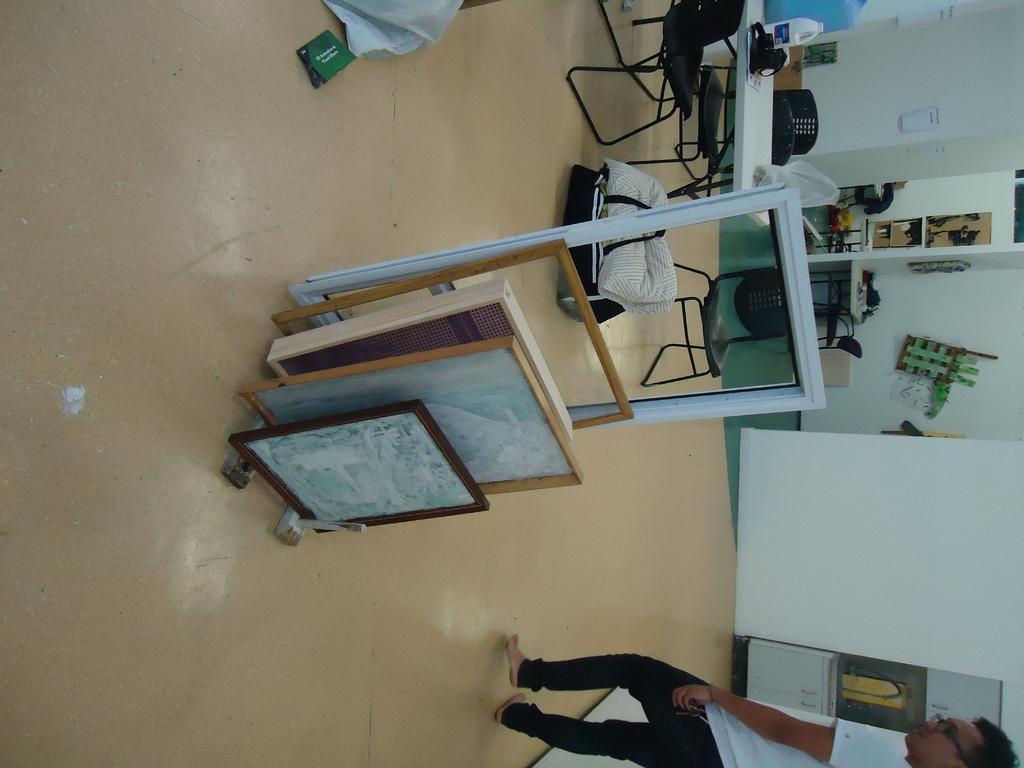How would you summarize this image in a sentence or two? In the image there are glass windows and various types of windows in the front and guy is stood at the left side and in the right side there is table and chairs in front. This seems to be of a work area. 